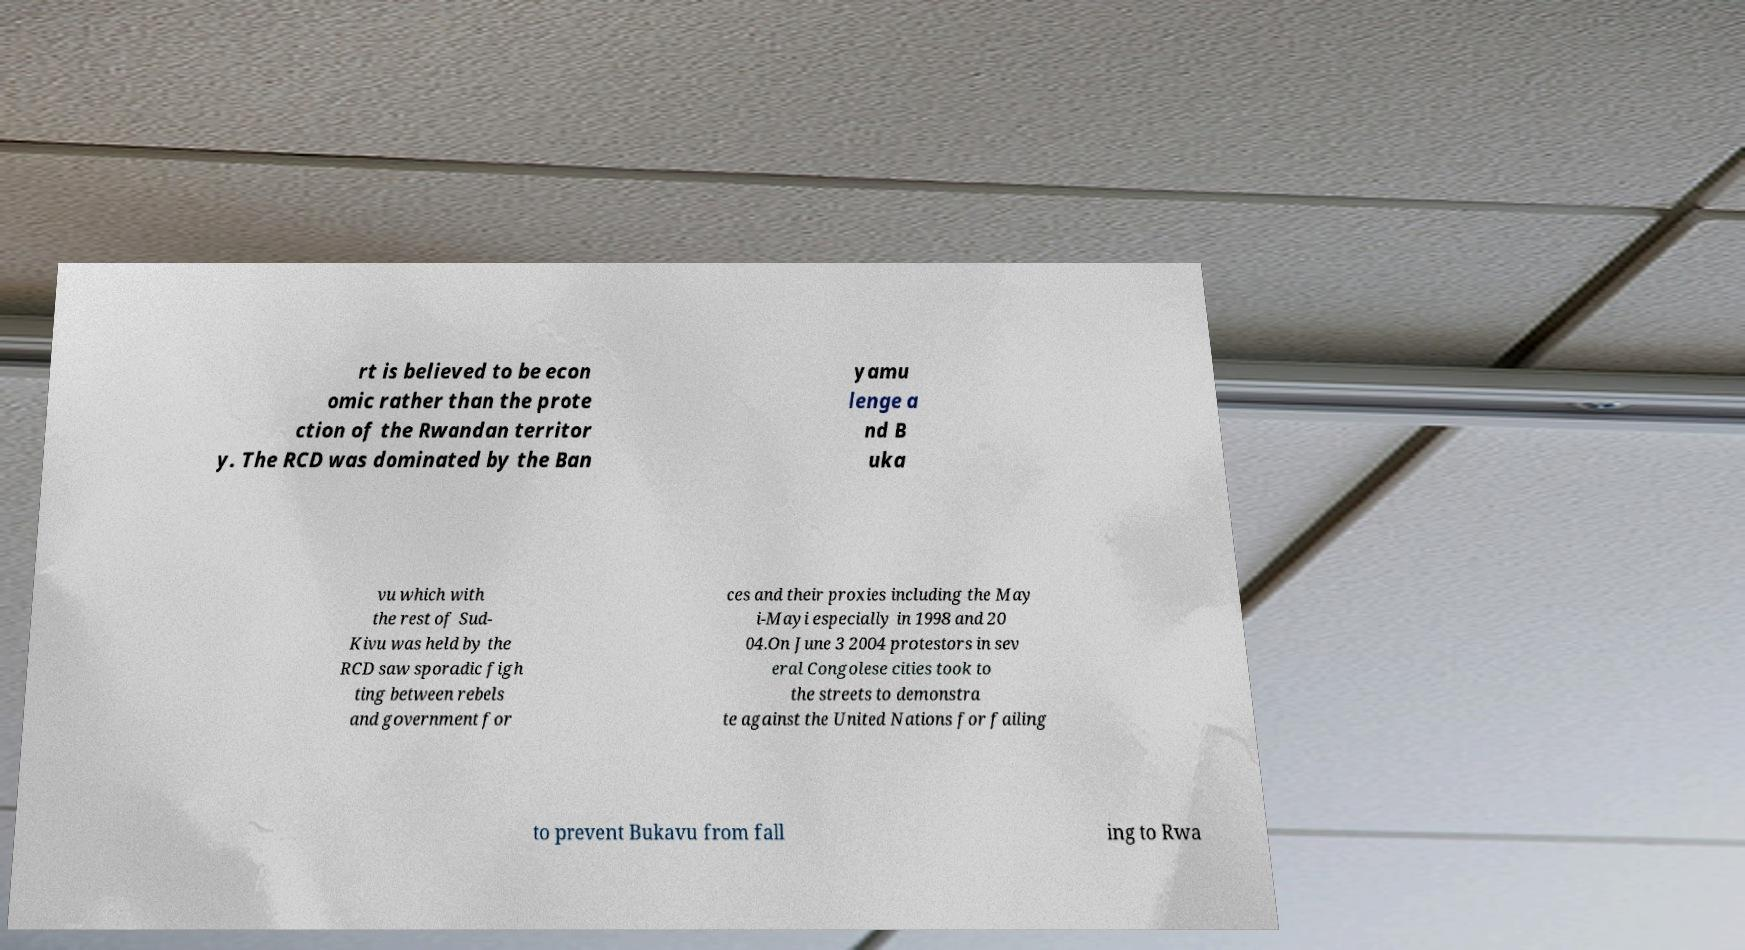There's text embedded in this image that I need extracted. Can you transcribe it verbatim? rt is believed to be econ omic rather than the prote ction of the Rwandan territor y. The RCD was dominated by the Ban yamu lenge a nd B uka vu which with the rest of Sud- Kivu was held by the RCD saw sporadic figh ting between rebels and government for ces and their proxies including the May i-Mayi especially in 1998 and 20 04.On June 3 2004 protestors in sev eral Congolese cities took to the streets to demonstra te against the United Nations for failing to prevent Bukavu from fall ing to Rwa 